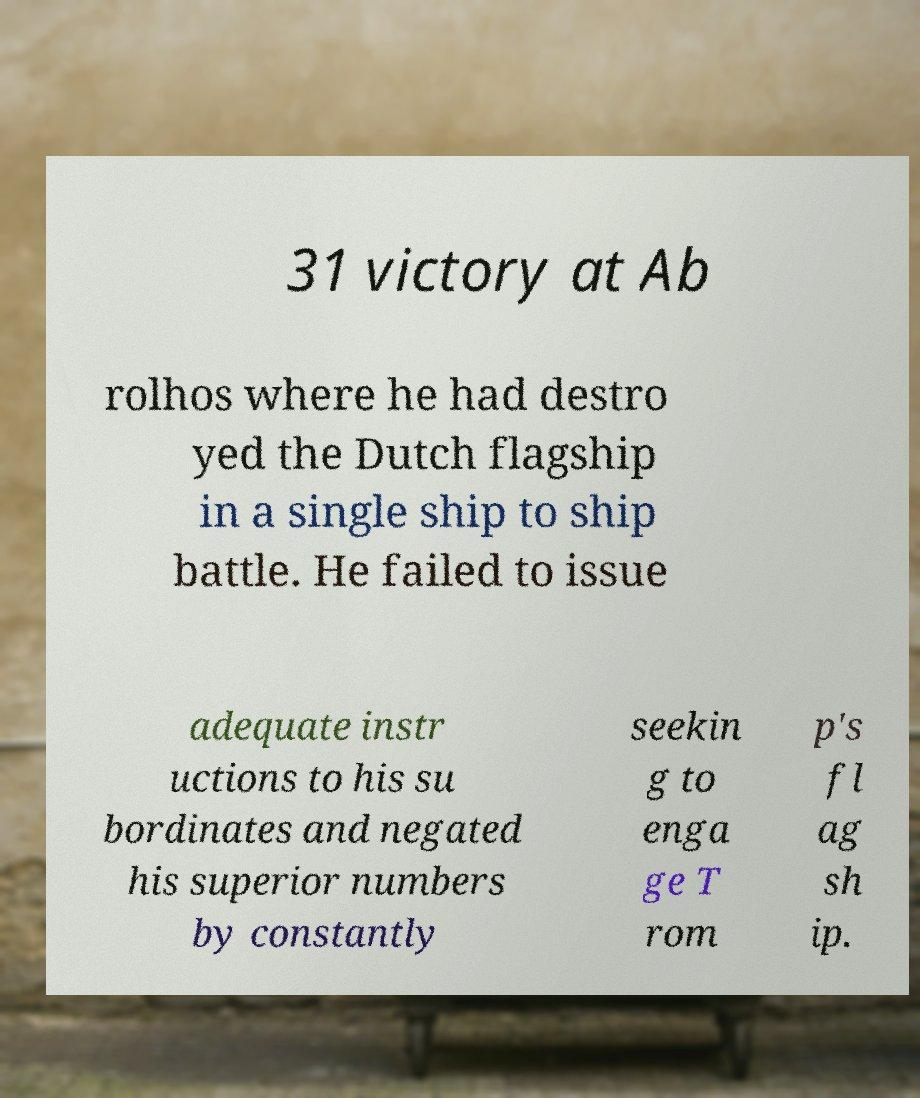What messages or text are displayed in this image? I need them in a readable, typed format. 31 victory at Ab rolhos where he had destro yed the Dutch flagship in a single ship to ship battle. He failed to issue adequate instr uctions to his su bordinates and negated his superior numbers by constantly seekin g to enga ge T rom p's fl ag sh ip. 